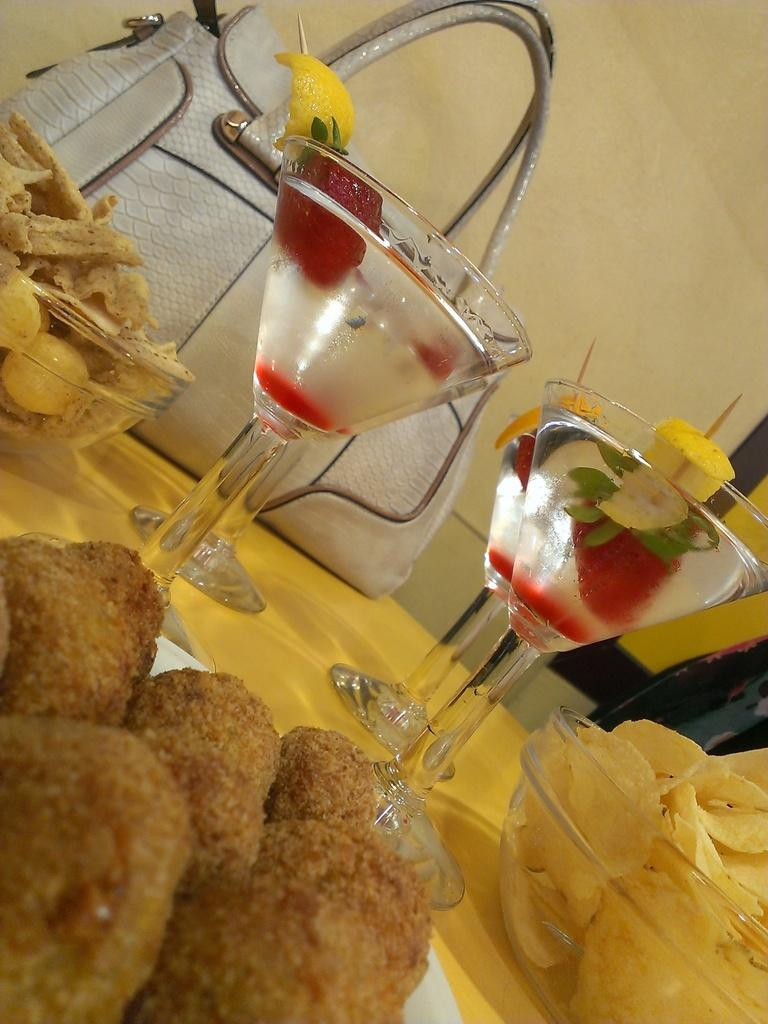What can be seen on the table in the image? There are different types of food on plates and bowls on a table. What else is present on the table besides food? There is a drink in glasses on the table. What is the color of the bag in the image? The bag in the image is white. What can be seen in the background of the image? There is a wall in the background. What type of story is being told by the food on the table? The food on the table is not telling a story; it is simply food on plates and bowls. Can you hear the ear in the image? There is no ear present in the image. 